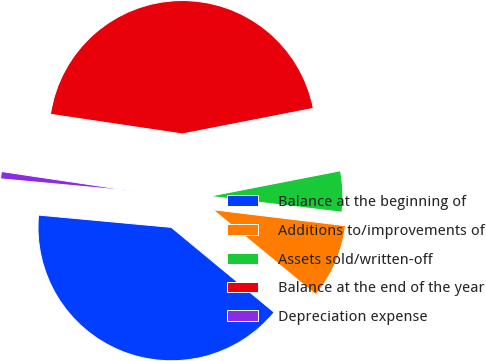Convert chart to OTSL. <chart><loc_0><loc_0><loc_500><loc_500><pie_chart><fcel>Balance at the beginning of<fcel>Additions to/improvements of<fcel>Assets sold/written-off<fcel>Balance at the end of the year<fcel>Depreciation expense<nl><fcel>40.48%<fcel>9.08%<fcel>4.98%<fcel>44.58%<fcel>0.88%<nl></chart> 